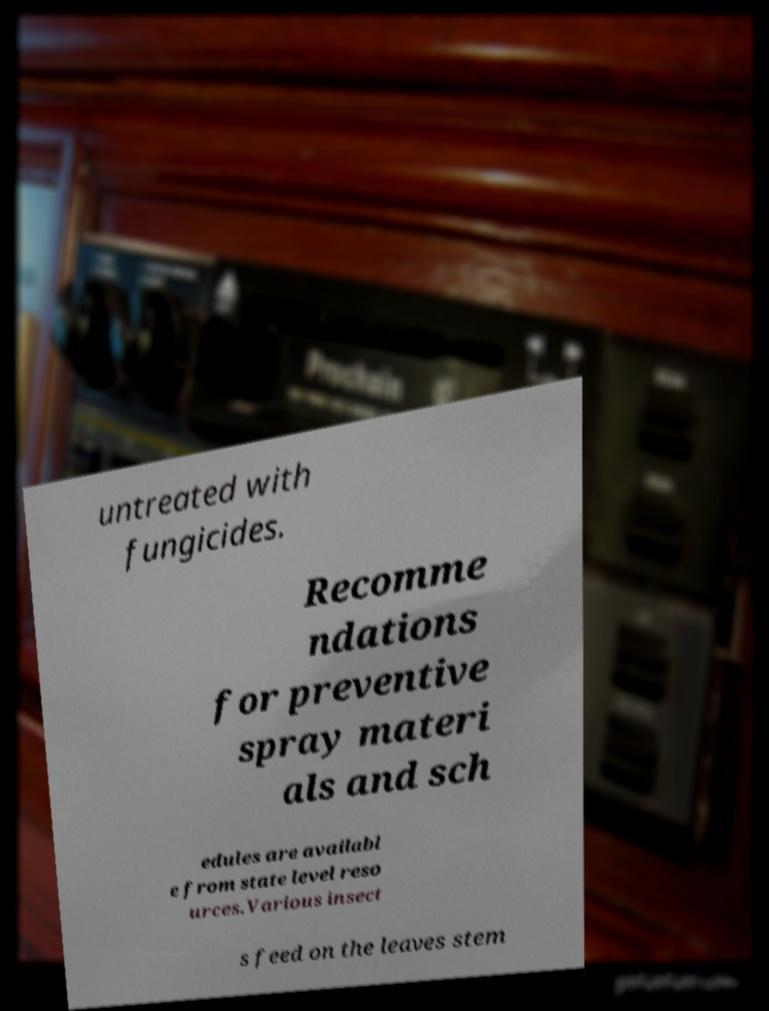Can you read and provide the text displayed in the image?This photo seems to have some interesting text. Can you extract and type it out for me? untreated with fungicides. Recomme ndations for preventive spray materi als and sch edules are availabl e from state level reso urces.Various insect s feed on the leaves stem 